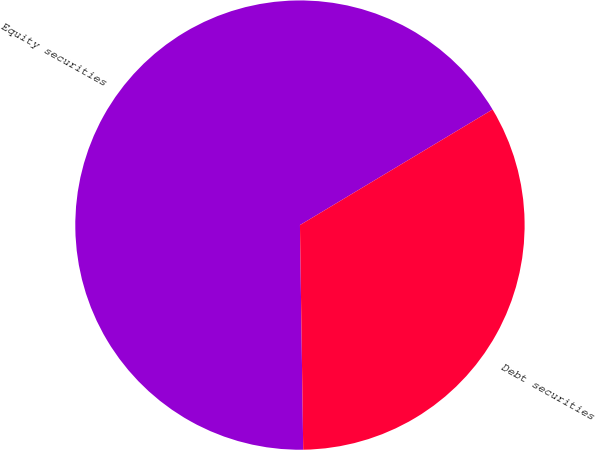<chart> <loc_0><loc_0><loc_500><loc_500><pie_chart><fcel>Equity securities<fcel>Debt securities<nl><fcel>66.63%<fcel>33.37%<nl></chart> 